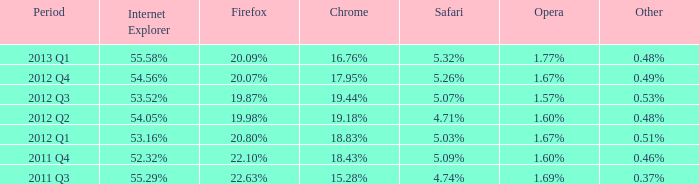What is the other that has 20.80% as the firefox? 0.51%. 